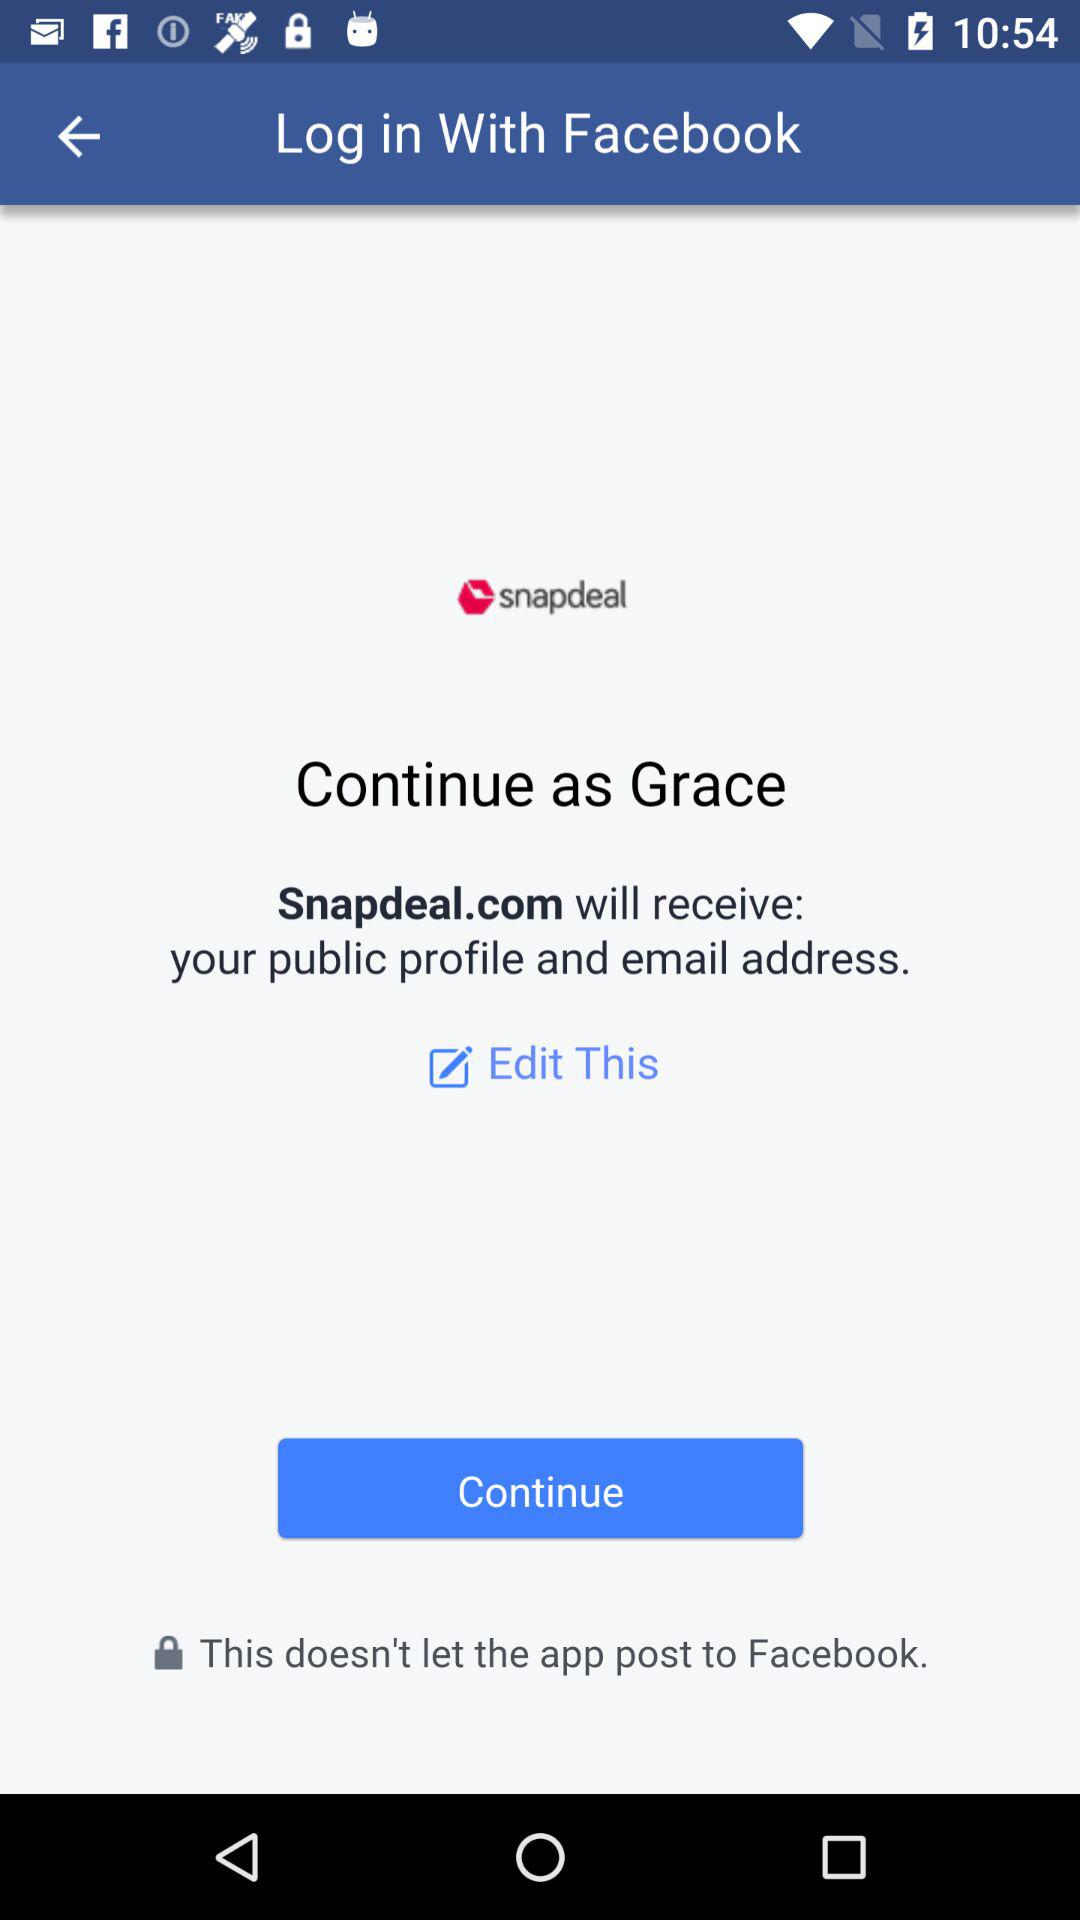What application is used to log in? The application is "Facebook". 